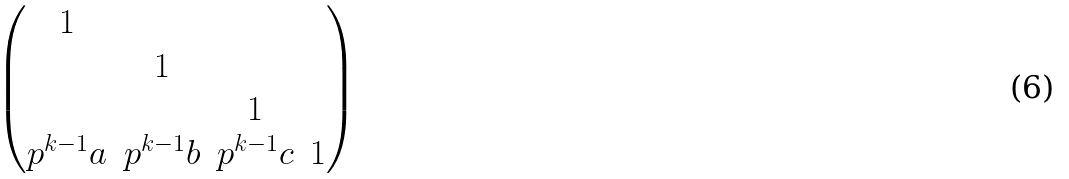<formula> <loc_0><loc_0><loc_500><loc_500>\begin{pmatrix} 1 & & & \\ & 1 & & \\ & & 1 & \\ p ^ { k - 1 } a & p ^ { k - 1 } b & p ^ { k - 1 } c & 1 \end{pmatrix}</formula> 